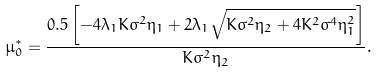Convert formula to latex. <formula><loc_0><loc_0><loc_500><loc_500>\mu _ { 0 } ^ { * } = \frac { 0 . 5 \left [ - 4 \lambda _ { 1 } K \sigma ^ { 2 } \eta _ { 1 } + 2 \lambda _ { 1 } \sqrt { K \sigma ^ { 2 } \eta _ { 2 } + 4 K ^ { 2 } \sigma ^ { 4 } \eta _ { 1 } ^ { 2 } } \right ] } { K \sigma ^ { 2 } \eta _ { 2 } } .</formula> 